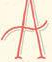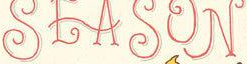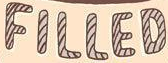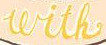Identify the words shown in these images in order, separated by a semicolon. A; SEASON; FILLED; with 